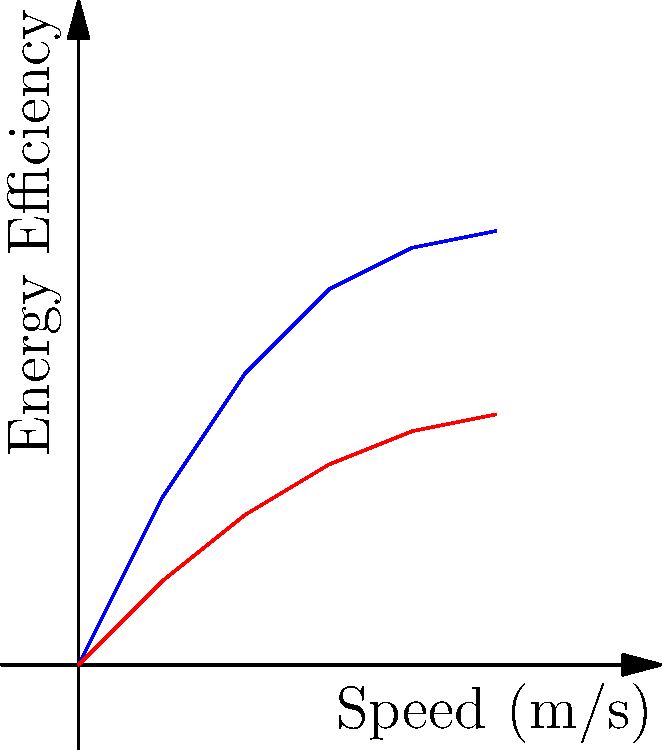Based on the graph showing the relationship between speed and energy efficiency for two different electric car designs, which shape is likely to have better energy efficiency at higher speeds, and why? To answer this question, let's analyze the graph step-by-step:

1. The graph shows two lines representing the energy efficiency of two different car designs at various speeds.

2. The blue line, labeled "Aerodynamic," has a steeper slope and reaches higher energy efficiency values.

3. The red line, labeled "Less Aerodynamic," has a gentler slope and achieves lower energy efficiency values.

4. As speed increases (moving right on the x-axis), the gap between the two lines widens.

5. At higher speeds (right side of the graph), the aerodynamic design (blue line) shows significantly higher energy efficiency compared to the less aerodynamic design (red line).

6. This is because aerodynamic shapes reduce air resistance (drag) as speed increases, allowing the car to maintain higher energy efficiency.

7. The less aerodynamic shape experiences more drag at higher speeds, resulting in lower energy efficiency.

Therefore, the aerodynamic shape (represented by the blue line) is likely to have better energy efficiency at higher speeds due to its ability to reduce air resistance and maintain efficiency as speed increases.
Answer: Aerodynamic shape (blue line) 